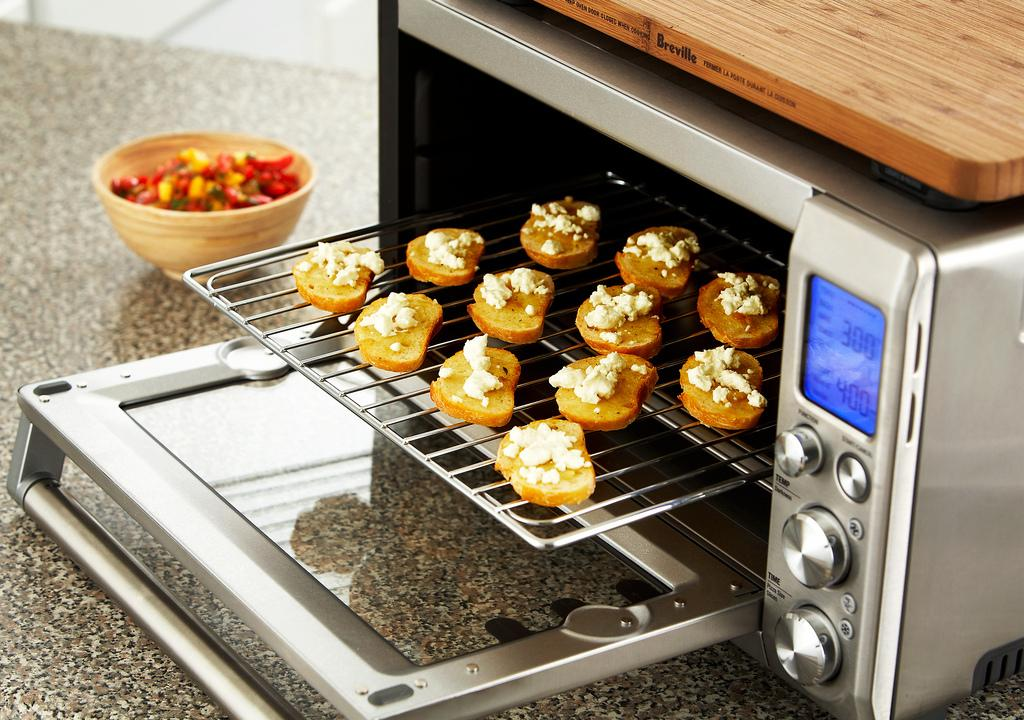<image>
Write a terse but informative summary of the picture. A toaster oven with brushetta inside has been set to 300F 